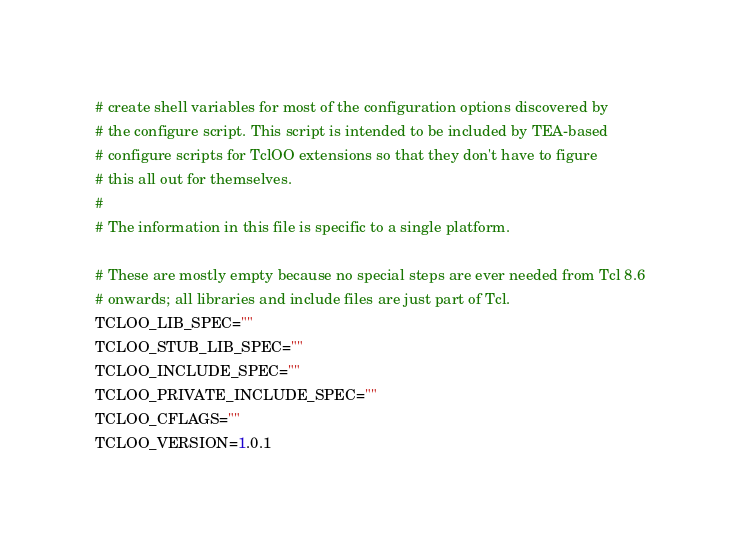Convert code to text. <code><loc_0><loc_0><loc_500><loc_500><_Bash_># create shell variables for most of the configuration options discovered by
# the configure script. This script is intended to be included by TEA-based
# configure scripts for TclOO extensions so that they don't have to figure
# this all out for themselves.
#
# The information in this file is specific to a single platform.

# These are mostly empty because no special steps are ever needed from Tcl 8.6
# onwards; all libraries and include files are just part of Tcl.
TCLOO_LIB_SPEC=""
TCLOO_STUB_LIB_SPEC=""
TCLOO_INCLUDE_SPEC=""
TCLOO_PRIVATE_INCLUDE_SPEC=""
TCLOO_CFLAGS=""
TCLOO_VERSION=1.0.1
</code> 